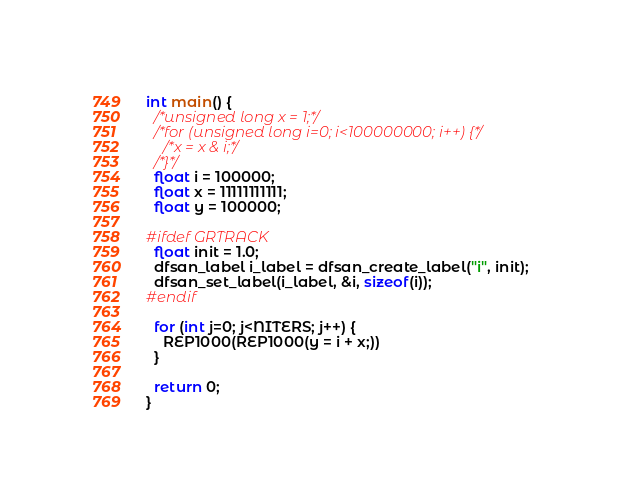Convert code to text. <code><loc_0><loc_0><loc_500><loc_500><_C_>
int main() {
  /*unsigned long x = 1;*/
  /*for (unsigned long i=0; i<100000000; i++) {*/
    /*x = x & i;*/
  /*}*/
  float i = 100000;
  float x = 11111111111;
  float y = 100000;

#ifdef GRTRACK
  float init = 1.0;
  dfsan_label i_label = dfsan_create_label("i", init);
  dfsan_set_label(i_label, &i, sizeof(i));
#endif

  for (int j=0; j<NITERS; j++) {
    REP1000(REP1000(y = i + x;))
  }

  return 0;
}

</code> 